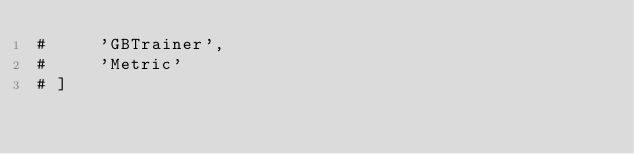<code> <loc_0><loc_0><loc_500><loc_500><_Python_>#     'GBTrainer',
#     'Metric'
# ]</code> 